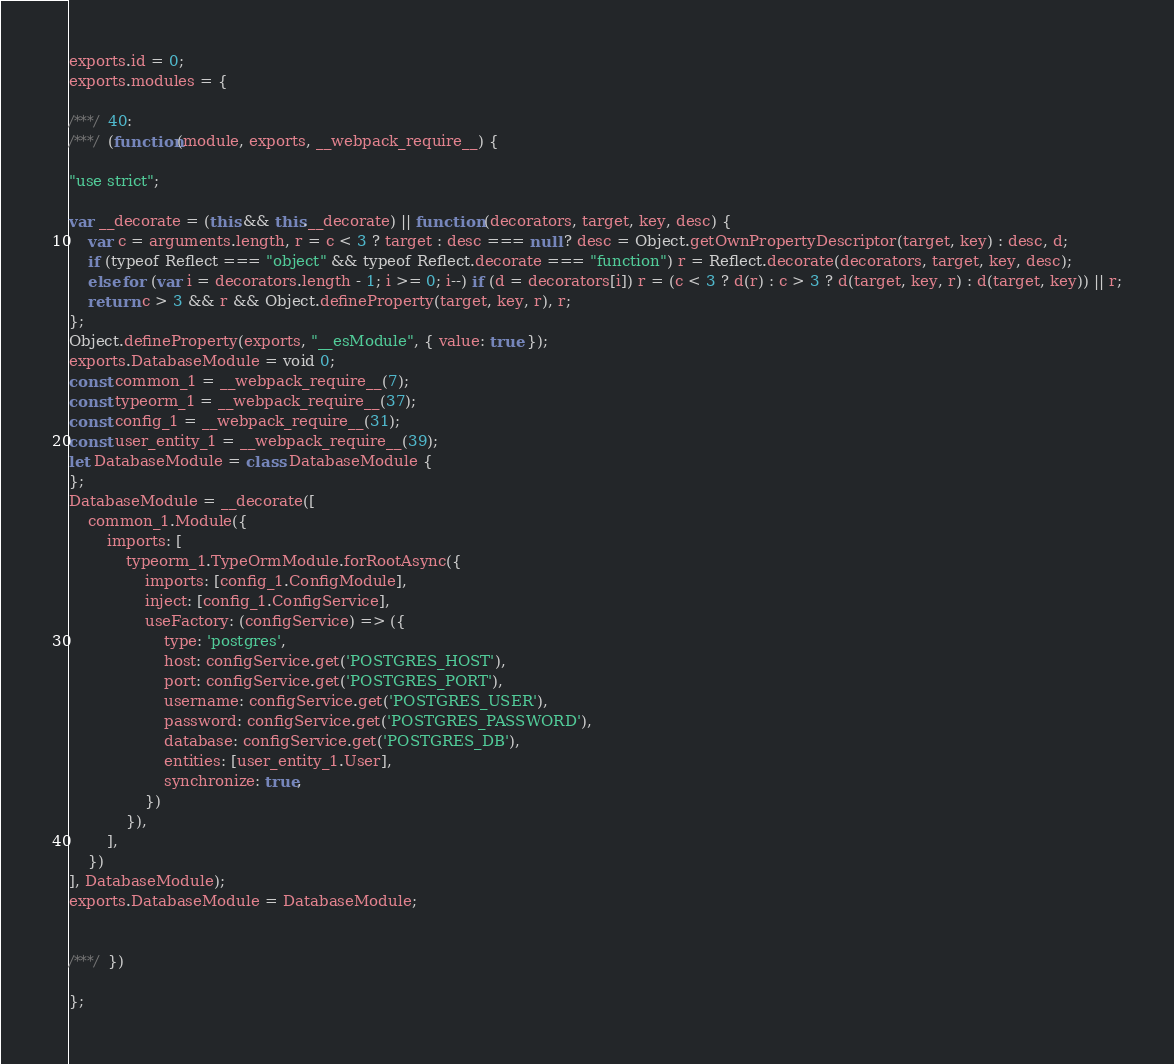<code> <loc_0><loc_0><loc_500><loc_500><_JavaScript_>exports.id = 0;
exports.modules = {

/***/ 40:
/***/ (function(module, exports, __webpack_require__) {

"use strict";

var __decorate = (this && this.__decorate) || function (decorators, target, key, desc) {
    var c = arguments.length, r = c < 3 ? target : desc === null ? desc = Object.getOwnPropertyDescriptor(target, key) : desc, d;
    if (typeof Reflect === "object" && typeof Reflect.decorate === "function") r = Reflect.decorate(decorators, target, key, desc);
    else for (var i = decorators.length - 1; i >= 0; i--) if (d = decorators[i]) r = (c < 3 ? d(r) : c > 3 ? d(target, key, r) : d(target, key)) || r;
    return c > 3 && r && Object.defineProperty(target, key, r), r;
};
Object.defineProperty(exports, "__esModule", { value: true });
exports.DatabaseModule = void 0;
const common_1 = __webpack_require__(7);
const typeorm_1 = __webpack_require__(37);
const config_1 = __webpack_require__(31);
const user_entity_1 = __webpack_require__(39);
let DatabaseModule = class DatabaseModule {
};
DatabaseModule = __decorate([
    common_1.Module({
        imports: [
            typeorm_1.TypeOrmModule.forRootAsync({
                imports: [config_1.ConfigModule],
                inject: [config_1.ConfigService],
                useFactory: (configService) => ({
                    type: 'postgres',
                    host: configService.get('POSTGRES_HOST'),
                    port: configService.get('POSTGRES_PORT'),
                    username: configService.get('POSTGRES_USER'),
                    password: configService.get('POSTGRES_PASSWORD'),
                    database: configService.get('POSTGRES_DB'),
                    entities: [user_entity_1.User],
                    synchronize: true,
                })
            }),
        ],
    })
], DatabaseModule);
exports.DatabaseModule = DatabaseModule;


/***/ })

};</code> 